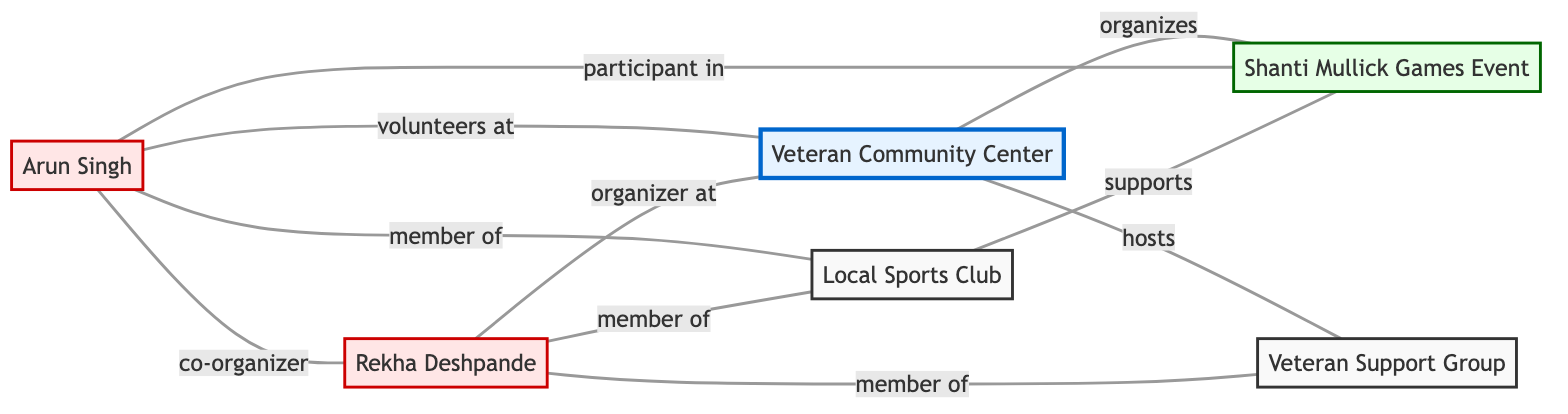What is the total number of nodes in the diagram? The nodes in the diagram are: Veteran Community Center, Arun Singh, Shanti Mullick Games Event, Local Sports Club, Rekha Deshpande, and Veteran Support Group. Counting these, we find there are 6 nodes in total.
Answer: 6 Which entity organizes the Shanti Mullick Games Event? According to the diagram, the Veteran Community Center organizes the Shanti Mullick Games Event as indicated by the connection labeled 'organizes'.
Answer: Veteran Community Center Who is involved as a co-organizer with Arun Singh? The connection between Arun Singh and Rekha Deshpande is labeled with 'co_organizer', indicating that Rekha Deshpande is the co-organizer with Arun Singh.
Answer: Rekha Deshpande What is the nature of the relationship between the Local Sports Club and the Shanti Mullick Games Event? The edge between Local Sports Club and Shanti Mullick Games Event shows the relationship is 'supports', indicating that Local Sports Club supports the event.
Answer: supports How many members are listed in the Veteran Support Group? In the diagram, Rekha Deshpande is the only member listed in connection to the Veteran Support Group, indicating that there is just one member in this context.
Answer: 1 Which node is directly connected to the Veteran Community Center that is an event? The Shanti Mullick Games Event is directly connected to the Veteran Community Center with the relationship labeled 'organizes', indicating that it is indeed an event.
Answer: Shanti Mullick Games Event What is the relationship type between Rekha Deshpande and the Veteran Community Center? The edge connecting Rekha Deshpande and Veteran Community Center is labeled 'organizer_at', indicating the specific type of relationship between them.
Answer: organizer_at Which node does Arun Singh volunteer at? The connection labeled 'volunteers_at' directly links Arun Singh to the Veteran Community Center, indicating where he volunteers.
Answer: Veteran Community Center In total, how many edges are present in the diagram? The edges present are: Arun Singh to Veteran Community Center (volunteers_at), Arun Singh to Shanti Mullick Games Event (participant_in), Arun Singh to Local Sports Club (member_of), Veteran Community Center to Shanti Mullick Games Event (organizes), Local Sports Club to Shanti Mullick Games Event (supports), Rekha Deshpande to Veteran Community Center (organizer_at), Rekha Deshpande to Local Sports Club (member_of), Rekha Deshpande to Veteran Support Group (member_of), and Arun Singh to Rekha Deshpande (co_organizer), making a total of 9 edges.
Answer: 9 